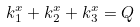<formula> <loc_0><loc_0><loc_500><loc_500>k _ { 1 } ^ { x } + k _ { 2 } ^ { x } + k _ { 3 } ^ { x } = Q</formula> 